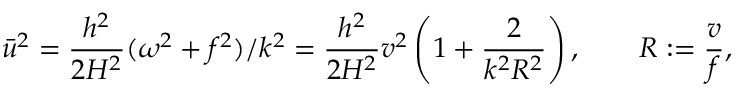Convert formula to latex. <formula><loc_0><loc_0><loc_500><loc_500>\bar { u } ^ { 2 } = \frac { h ^ { 2 } } { 2 H ^ { 2 } } ( \omega ^ { 2 } + f ^ { 2 } ) / k ^ { 2 } = \frac { h ^ { 2 } } { 2 H ^ { 2 } } v ^ { 2 } \left ( 1 + \frac { 2 } { k ^ { 2 } R ^ { 2 } } \right ) , \quad R \colon = \frac { v } { f } ,</formula> 